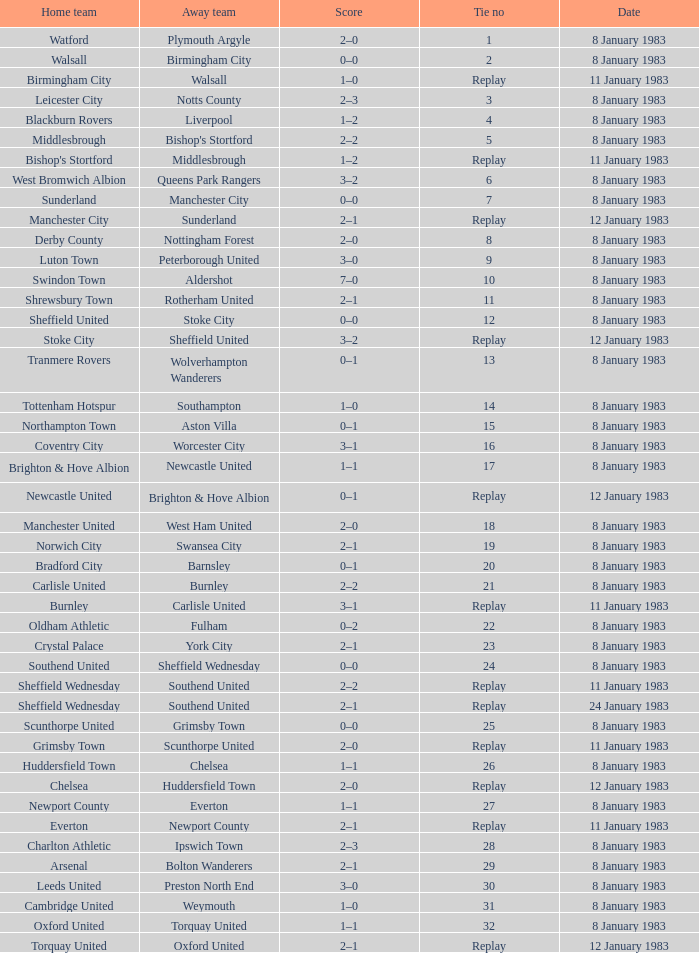On what date was Tie #13 played? 8 January 1983. 